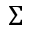<formula> <loc_0><loc_0><loc_500><loc_500>\Sigma</formula> 